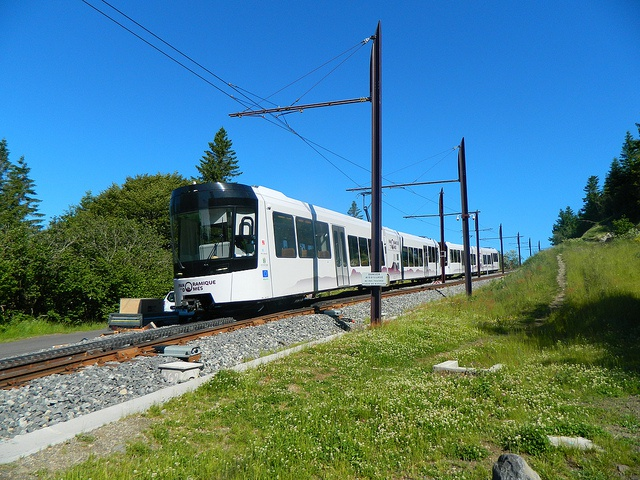Describe the objects in this image and their specific colors. I can see train in blue, black, lightgray, and gray tones and car in blue, black, white, and navy tones in this image. 